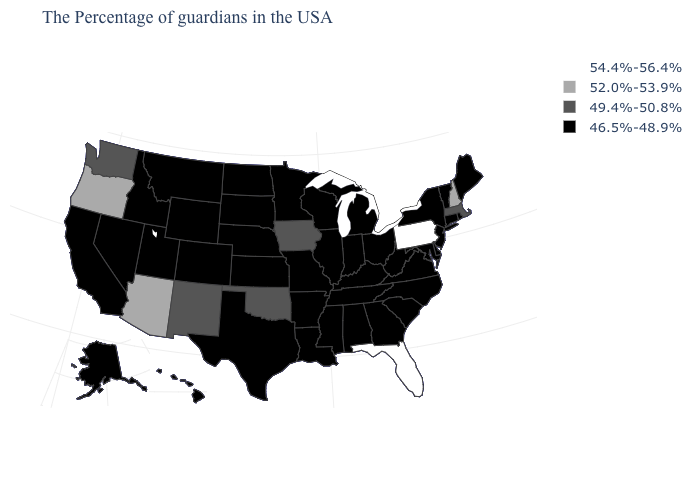What is the value of Massachusetts?
Be succinct. 49.4%-50.8%. Name the states that have a value in the range 46.5%-48.9%?
Write a very short answer. Maine, Rhode Island, Vermont, Connecticut, New York, New Jersey, Delaware, Maryland, Virginia, North Carolina, South Carolina, West Virginia, Ohio, Georgia, Michigan, Kentucky, Indiana, Alabama, Tennessee, Wisconsin, Illinois, Mississippi, Louisiana, Missouri, Arkansas, Minnesota, Kansas, Nebraska, Texas, South Dakota, North Dakota, Wyoming, Colorado, Utah, Montana, Idaho, Nevada, California, Alaska, Hawaii. Which states hav the highest value in the South?
Answer briefly. Florida. What is the value of Nevada?
Concise answer only. 46.5%-48.9%. Name the states that have a value in the range 52.0%-53.9%?
Quick response, please. New Hampshire, Arizona, Oregon. What is the lowest value in the South?
Answer briefly. 46.5%-48.9%. Does the first symbol in the legend represent the smallest category?
Quick response, please. No. What is the value of Oregon?
Short answer required. 52.0%-53.9%. What is the value of Mississippi?
Quick response, please. 46.5%-48.9%. Name the states that have a value in the range 46.5%-48.9%?
Give a very brief answer. Maine, Rhode Island, Vermont, Connecticut, New York, New Jersey, Delaware, Maryland, Virginia, North Carolina, South Carolina, West Virginia, Ohio, Georgia, Michigan, Kentucky, Indiana, Alabama, Tennessee, Wisconsin, Illinois, Mississippi, Louisiana, Missouri, Arkansas, Minnesota, Kansas, Nebraska, Texas, South Dakota, North Dakota, Wyoming, Colorado, Utah, Montana, Idaho, Nevada, California, Alaska, Hawaii. What is the value of Virginia?
Concise answer only. 46.5%-48.9%. Among the states that border Washington , which have the lowest value?
Quick response, please. Idaho. Does Oregon have the lowest value in the USA?
Be succinct. No. Which states have the highest value in the USA?
Concise answer only. Pennsylvania, Florida. Does Vermont have the highest value in the USA?
Concise answer only. No. 